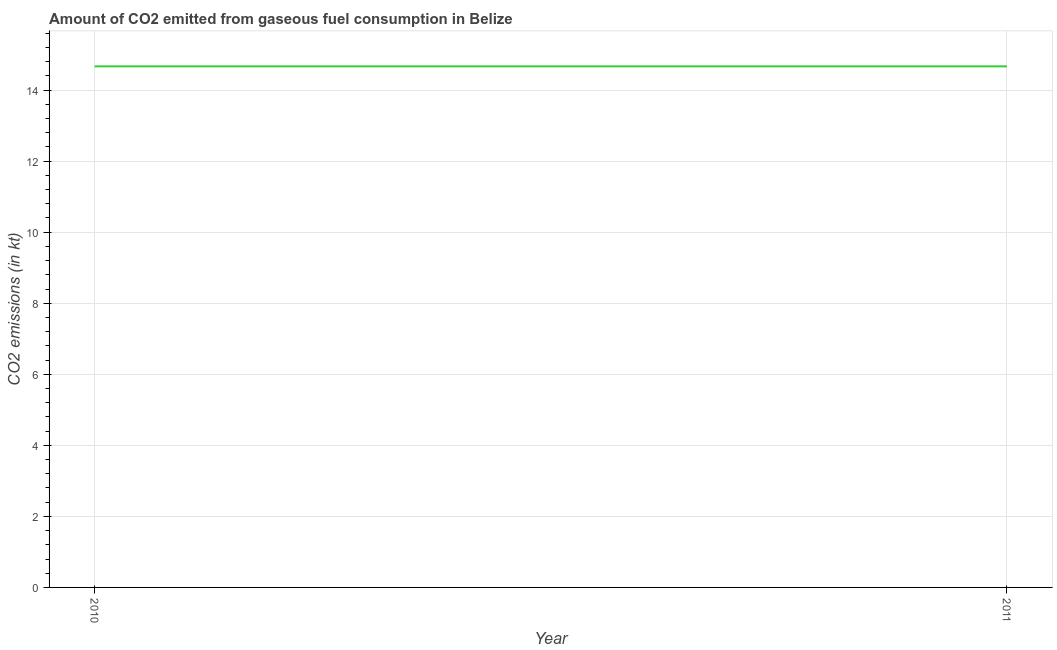What is the co2 emissions from gaseous fuel consumption in 2010?
Offer a terse response. 14.67. Across all years, what is the maximum co2 emissions from gaseous fuel consumption?
Give a very brief answer. 14.67. Across all years, what is the minimum co2 emissions from gaseous fuel consumption?
Your answer should be very brief. 14.67. In which year was the co2 emissions from gaseous fuel consumption minimum?
Your response must be concise. 2010. What is the sum of the co2 emissions from gaseous fuel consumption?
Give a very brief answer. 29.34. What is the difference between the co2 emissions from gaseous fuel consumption in 2010 and 2011?
Keep it short and to the point. 0. What is the average co2 emissions from gaseous fuel consumption per year?
Give a very brief answer. 14.67. What is the median co2 emissions from gaseous fuel consumption?
Provide a succinct answer. 14.67. In how many years, is the co2 emissions from gaseous fuel consumption greater than 4.8 kt?
Provide a succinct answer. 2. What is the ratio of the co2 emissions from gaseous fuel consumption in 2010 to that in 2011?
Provide a succinct answer. 1. In how many years, is the co2 emissions from gaseous fuel consumption greater than the average co2 emissions from gaseous fuel consumption taken over all years?
Offer a very short reply. 0. Does the co2 emissions from gaseous fuel consumption monotonically increase over the years?
Your answer should be compact. No. How many lines are there?
Ensure brevity in your answer.  1. How many years are there in the graph?
Provide a short and direct response. 2. What is the difference between two consecutive major ticks on the Y-axis?
Your answer should be compact. 2. Are the values on the major ticks of Y-axis written in scientific E-notation?
Give a very brief answer. No. Does the graph contain grids?
Provide a short and direct response. Yes. What is the title of the graph?
Your answer should be compact. Amount of CO2 emitted from gaseous fuel consumption in Belize. What is the label or title of the Y-axis?
Your answer should be very brief. CO2 emissions (in kt). What is the CO2 emissions (in kt) of 2010?
Offer a terse response. 14.67. What is the CO2 emissions (in kt) of 2011?
Keep it short and to the point. 14.67. What is the ratio of the CO2 emissions (in kt) in 2010 to that in 2011?
Your answer should be compact. 1. 